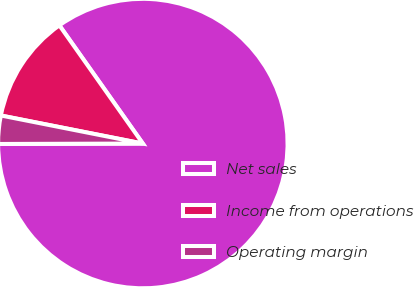Convert chart to OTSL. <chart><loc_0><loc_0><loc_500><loc_500><pie_chart><fcel>Net sales<fcel>Income from operations<fcel>Operating margin<nl><fcel>84.75%<fcel>12.11%<fcel>3.15%<nl></chart> 